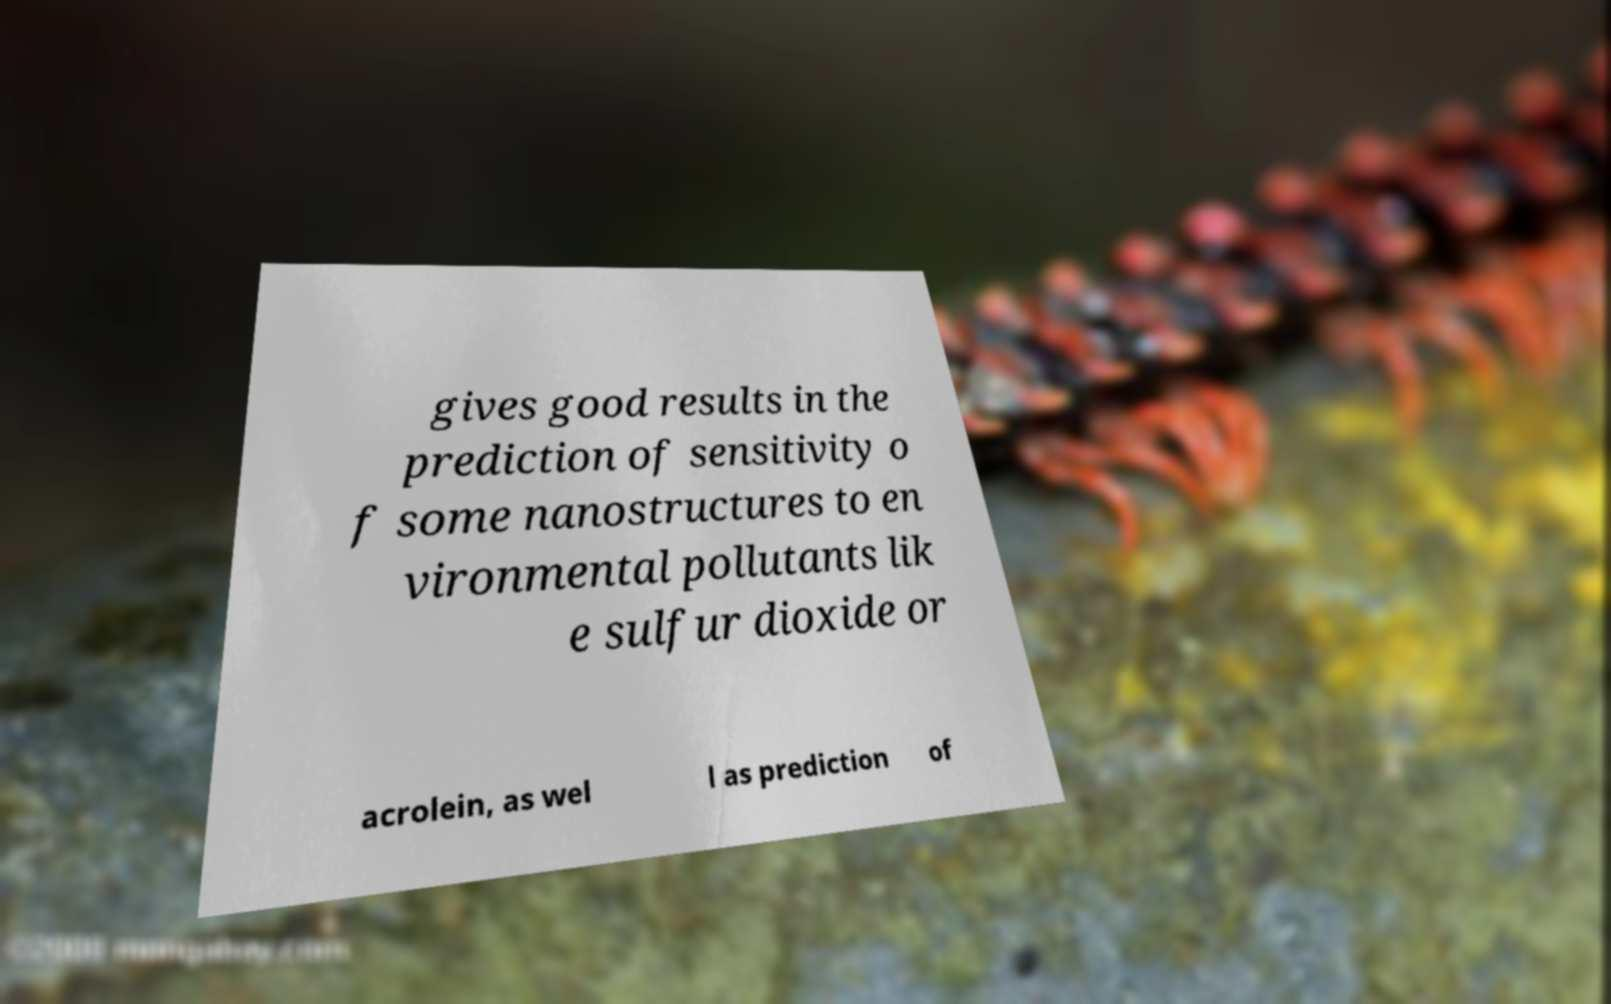Please read and relay the text visible in this image. What does it say? gives good results in the prediction of sensitivity o f some nanostructures to en vironmental pollutants lik e sulfur dioxide or acrolein, as wel l as prediction of 